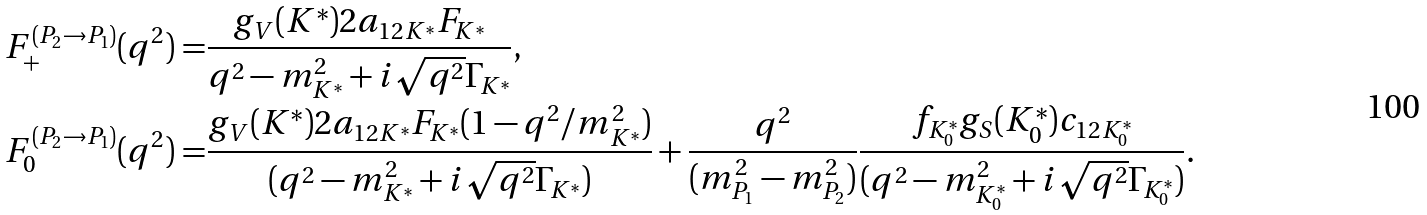<formula> <loc_0><loc_0><loc_500><loc_500>F _ { + } ^ { ( P _ { 2 } \to P _ { 1 } ) } ( q ^ { 2 } ) = & \frac { g _ { V } ( K ^ { * } ) 2 a _ { 1 2 K ^ { * } } F _ { K ^ { * } } } { q ^ { 2 } - m _ { K ^ { * } } ^ { 2 } + i \sqrt { q ^ { 2 } } \Gamma _ { K ^ { * } } } , \\ F _ { 0 } ^ { ( P _ { 2 } \to P _ { 1 } ) } ( q ^ { 2 } ) = & \frac { g _ { V } ( K ^ { * } ) 2 a _ { 1 2 K ^ { * } } F _ { K ^ { * } } ( 1 - q ^ { 2 } / m _ { K ^ { * } } ^ { 2 } ) } { ( q ^ { 2 } - m _ { K ^ { * } } ^ { 2 } + i \sqrt { q ^ { 2 } } \Gamma _ { K ^ { * } } ) } + \frac { q ^ { 2 } } { ( m _ { P _ { 1 } } ^ { 2 } - m _ { P _ { 2 } } ^ { 2 } ) } \frac { f _ { K _ { 0 } ^ { * } } g _ { S } ( K _ { 0 } ^ { * } ) c _ { 1 2 K _ { 0 } ^ { * } } } { ( q ^ { 2 } - m _ { K _ { 0 } ^ { * } } ^ { 2 } + i \sqrt { q ^ { 2 } } \Gamma _ { K _ { 0 } ^ { * } } ) } .</formula> 